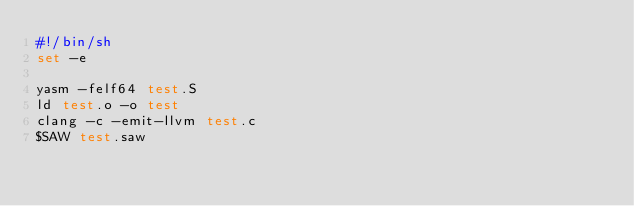<code> <loc_0><loc_0><loc_500><loc_500><_Bash_>#!/bin/sh
set -e

yasm -felf64 test.S
ld test.o -o test
clang -c -emit-llvm test.c
$SAW test.saw
</code> 